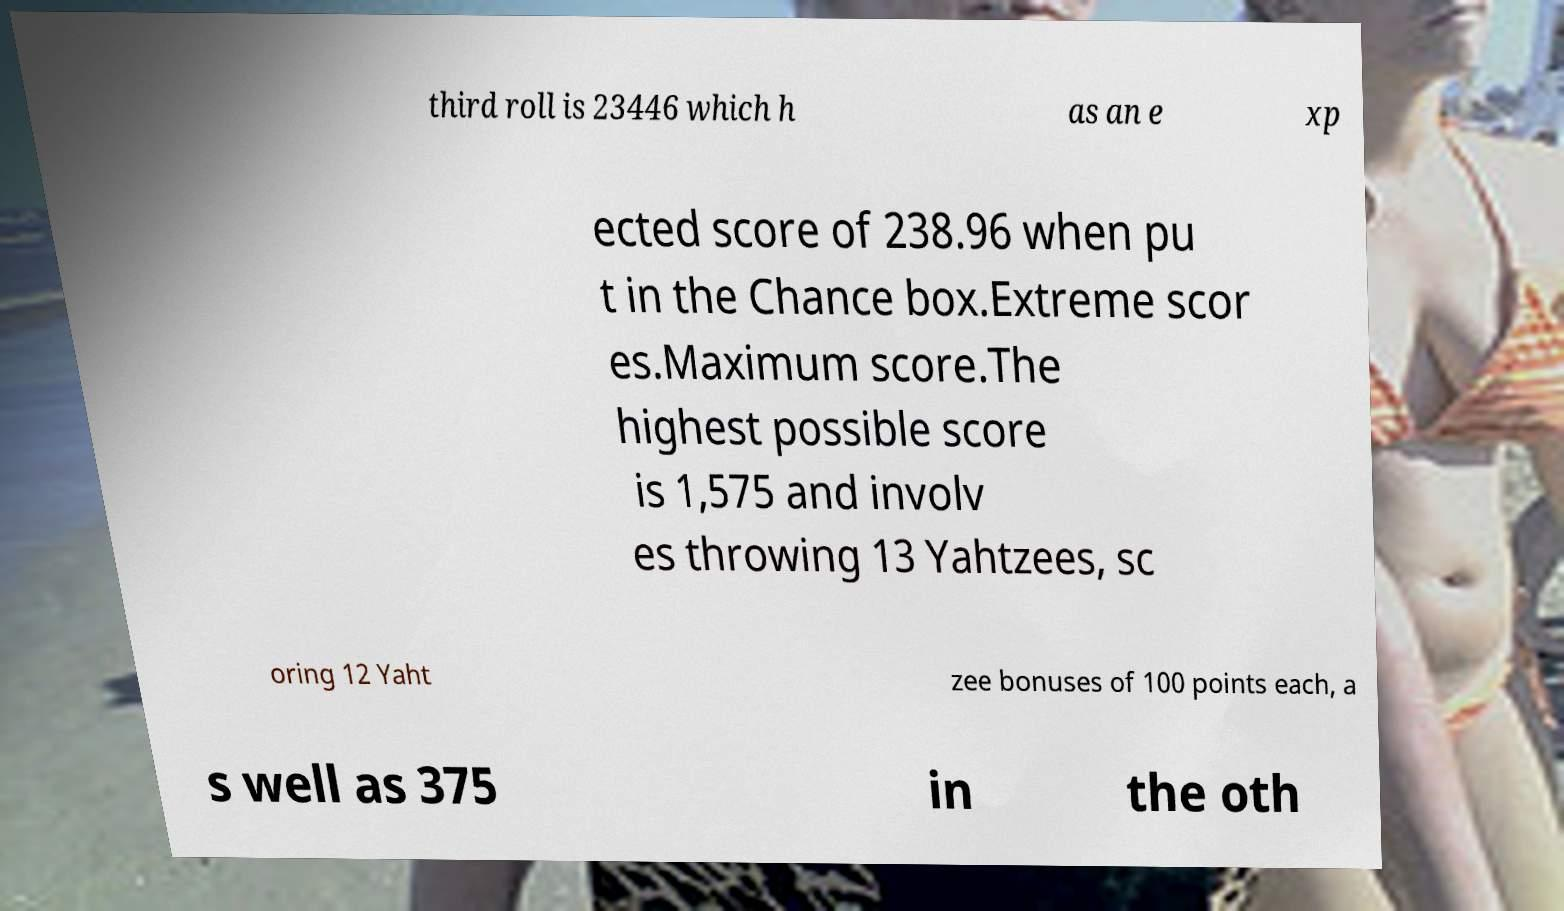What messages or text are displayed in this image? I need them in a readable, typed format. third roll is 23446 which h as an e xp ected score of 238.96 when pu t in the Chance box.Extreme scor es.Maximum score.The highest possible score is 1,575 and involv es throwing 13 Yahtzees, sc oring 12 Yaht zee bonuses of 100 points each, a s well as 375 in the oth 